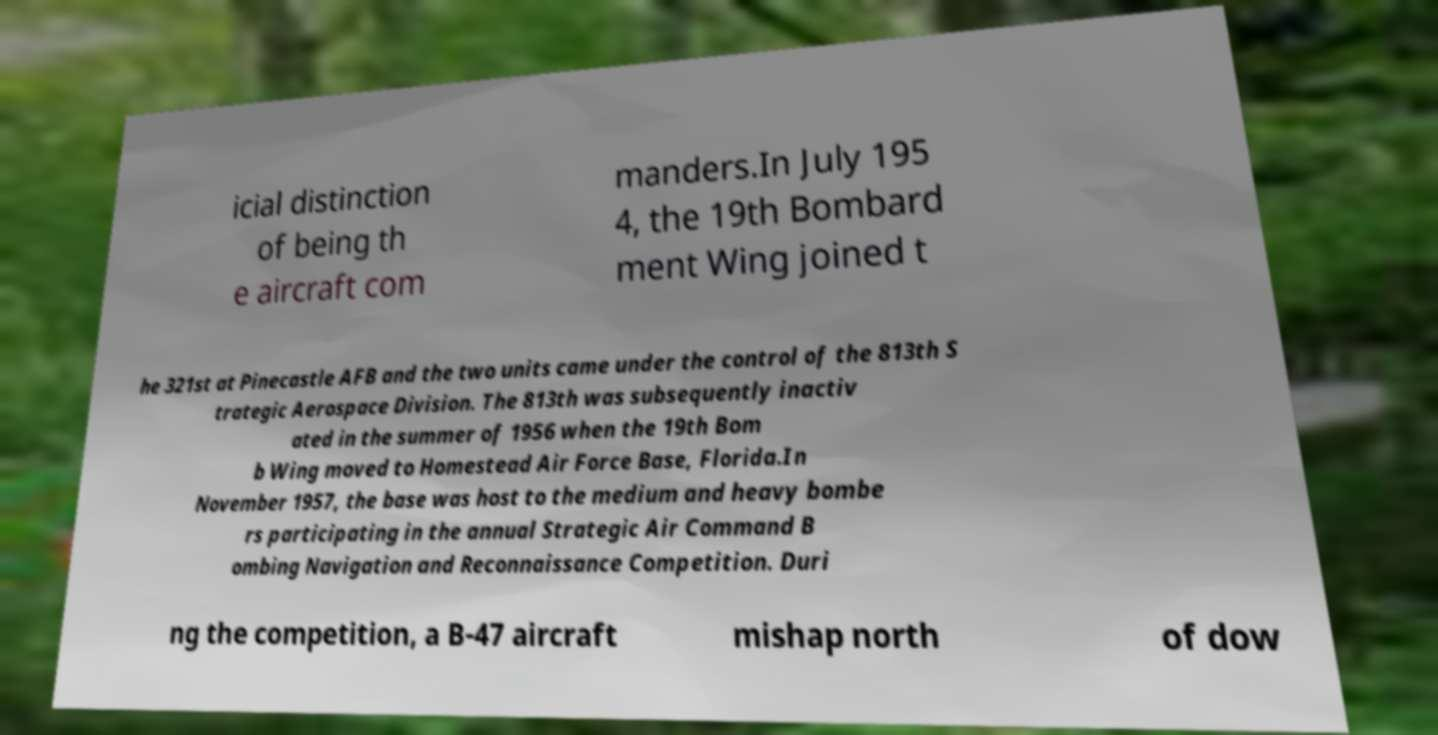What messages or text are displayed in this image? I need them in a readable, typed format. icial distinction of being th e aircraft com manders.In July 195 4, the 19th Bombard ment Wing joined t he 321st at Pinecastle AFB and the two units came under the control of the 813th S trategic Aerospace Division. The 813th was subsequently inactiv ated in the summer of 1956 when the 19th Bom b Wing moved to Homestead Air Force Base, Florida.In November 1957, the base was host to the medium and heavy bombe rs participating in the annual Strategic Air Command B ombing Navigation and Reconnaissance Competition. Duri ng the competition, a B-47 aircraft mishap north of dow 